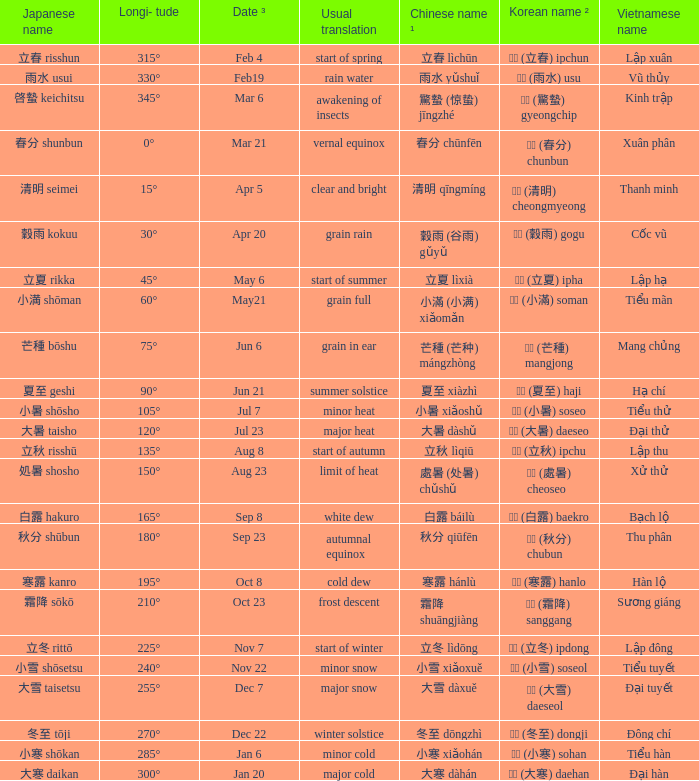Which Japanese name has a Korean name ² of 경칩 (驚蟄) gyeongchip? 啓蟄 keichitsu. 